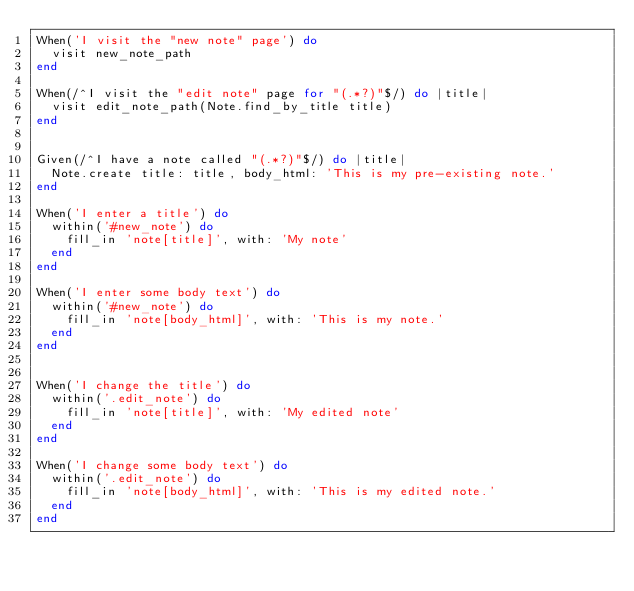Convert code to text. <code><loc_0><loc_0><loc_500><loc_500><_Ruby_>When('I visit the "new note" page') do
  visit new_note_path
end

When(/^I visit the "edit note" page for "(.*?)"$/) do |title|
  visit edit_note_path(Note.find_by_title title)
end


Given(/^I have a note called "(.*?)"$/) do |title|
  Note.create title: title, body_html: 'This is my pre-existing note.'
end

When('I enter a title') do
  within('#new_note') do
    fill_in 'note[title]', with: 'My note'
  end
end

When('I enter some body text') do
  within('#new_note') do
    fill_in 'note[body_html]', with: 'This is my note.'
  end
end


When('I change the title') do
  within('.edit_note') do
    fill_in 'note[title]', with: 'My edited note'
  end
end

When('I change some body text') do
  within('.edit_note') do
    fill_in 'note[body_html]', with: 'This is my edited note.'
  end
end
</code> 